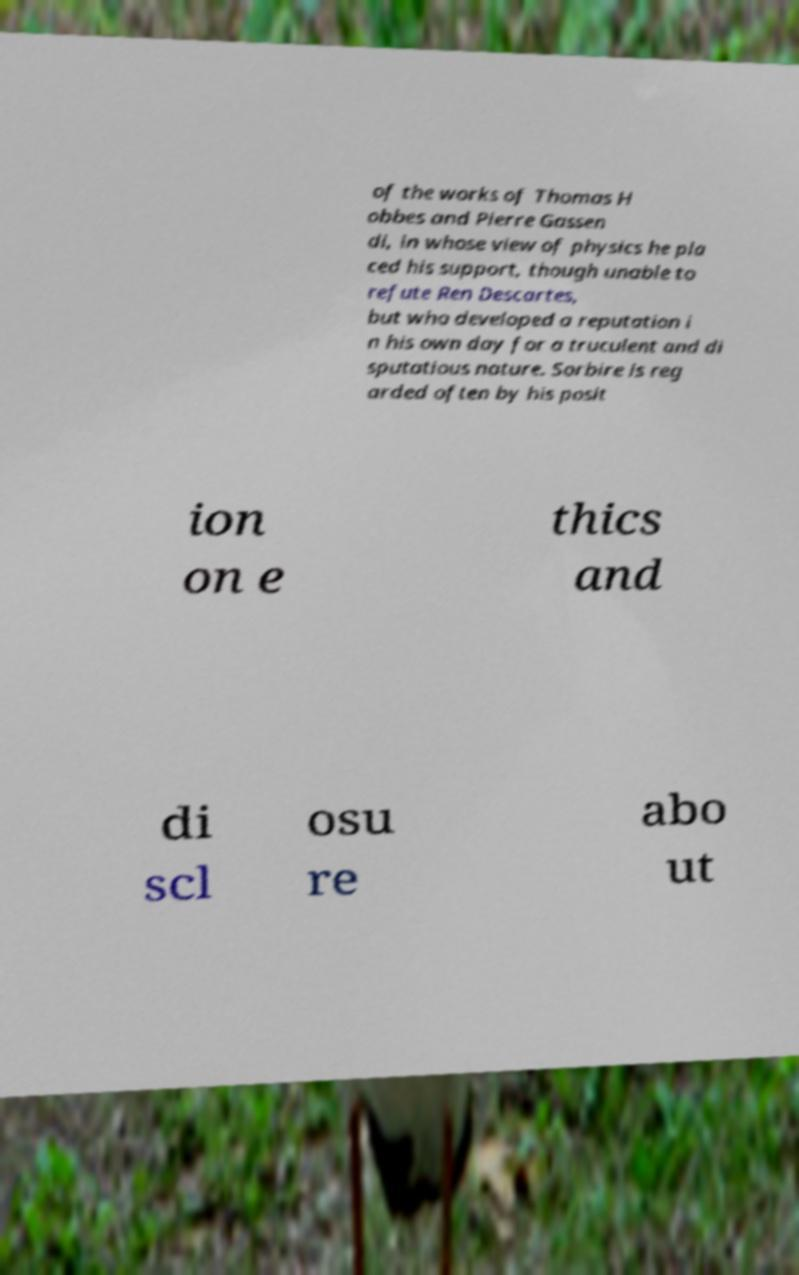I need the written content from this picture converted into text. Can you do that? of the works of Thomas H obbes and Pierre Gassen di, in whose view of physics he pla ced his support, though unable to refute Ren Descartes, but who developed a reputation i n his own day for a truculent and di sputatious nature. Sorbire is reg arded often by his posit ion on e thics and di scl osu re abo ut 